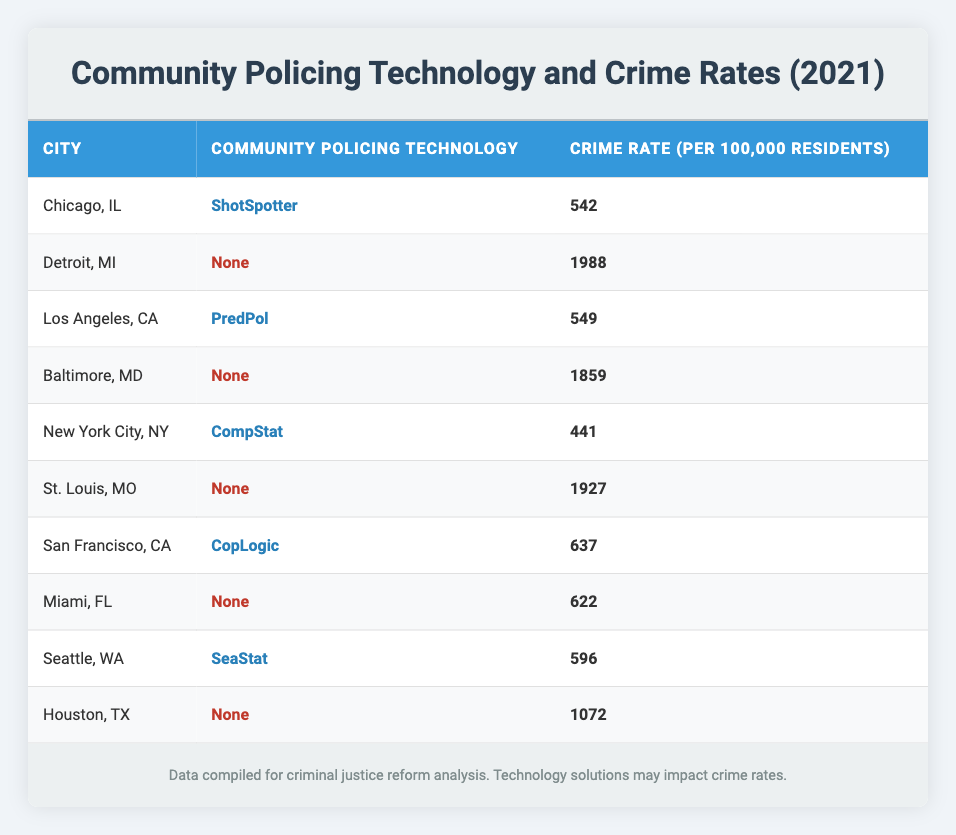What is the highest crime rate among the cities listed? The crime rates in the table vary across different cities. Upon reviewing the Crime Rate column, the highest value is found in Baltimore, MD, with a crime rate of 1859 per 100,000 residents.
Answer: 1859 Which city has the lowest crime rate? To find the lowest crime rate, we look through the Crime Rate column. The lowest value is 441 per 100,000 residents, which corresponds to New York City, NY.
Answer: 441 What is the total crime rate for cities using community policing technology? For this calculation, we first identify the cities using community policing technology: Chicago, IL (542), Los Angeles, CA (549), New York City, NY (441), San Francisco, CA (637), and Seattle, WA (596). Adding these rates together gives us 542 + 549 + 441 + 637 + 596 = 2765. Therefore, the total crime rate for these cities is 2765.
Answer: 2765 How many cities in the table are using community policing technology? By examining the table, we identify the cities with community policing technology: Chicago, IL; Los Angeles, CA; New York City, NY; San Francisco, CA; and Seattle, WA. This totals five cities using community policing technology.
Answer: 5 Is the crime rate in Detroit higher than the crime rate in Chicago? To answer this, we compare the crime rates: Detroit has a crime rate of 1988, while Chicago has a crime rate of 542. Since 1988 is greater than 542, the statement is true.
Answer: Yes What is the average crime rate for cities without community policing technologies? First, we need to identify the cities without community policing tech: Detroit, MI (1988), Baltimore, MD (1859), St. Louis, MO (1927), Miami, FL (622), and Houston, TX (1072). Summing these gives us 1988 + 1859 + 1927 + 622 + 1072 = 7468. Since there are five cities, the average is 7468 / 5 = 1493.6.
Answer: 1493.6 Are there more cities with or without community policing technology? Counting the number of cities with community policing technology, we have five: Chicago, Los Angeles, New York City, San Francisco, and Seattle. For cities without it, we have Detroit, Baltimore, St. Louis, Miami, and Houston (also five cities). Since both counts are equal, the answer is no.
Answer: No Which city has a crime rate closest to the average crime rate of cities using community policing technology? First, we calculate the average crime rate for cities using community policing technologies: Chicago (542), Los Angeles (549), New York City (441), San Francisco (637), Seattle (596). The average is (542 + 549 + 441 + 637 + 596) / 5 = 552.2. Now we look for the city closest to this value: Chicago (542) and Los Angeles (549) are both very close.
Answer: Chicago and Los Angeles 